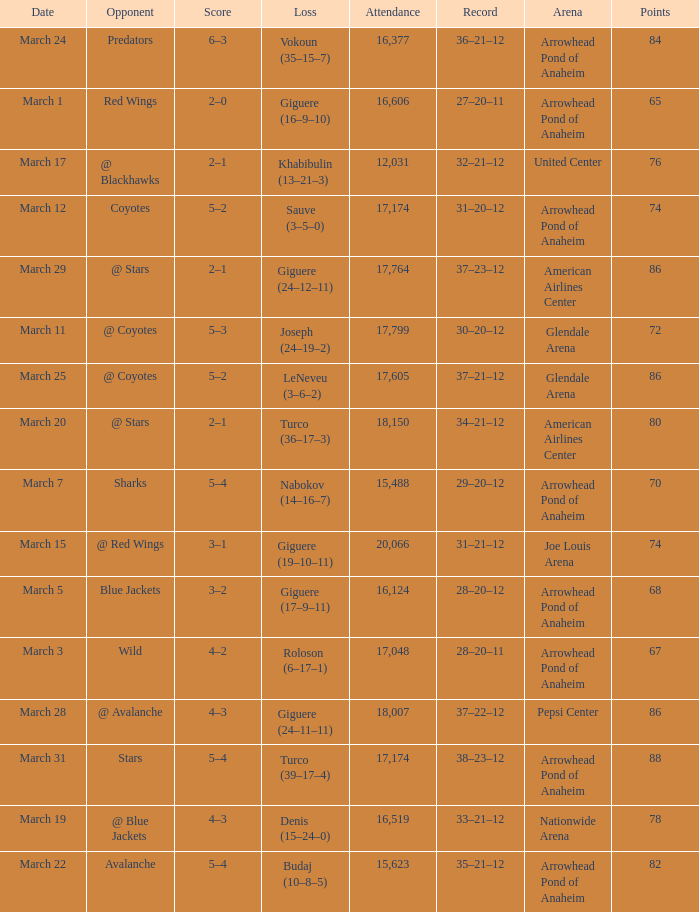What is the Loss of the game at Nationwide Arena with a Score of 4–3? Denis (15–24–0). 